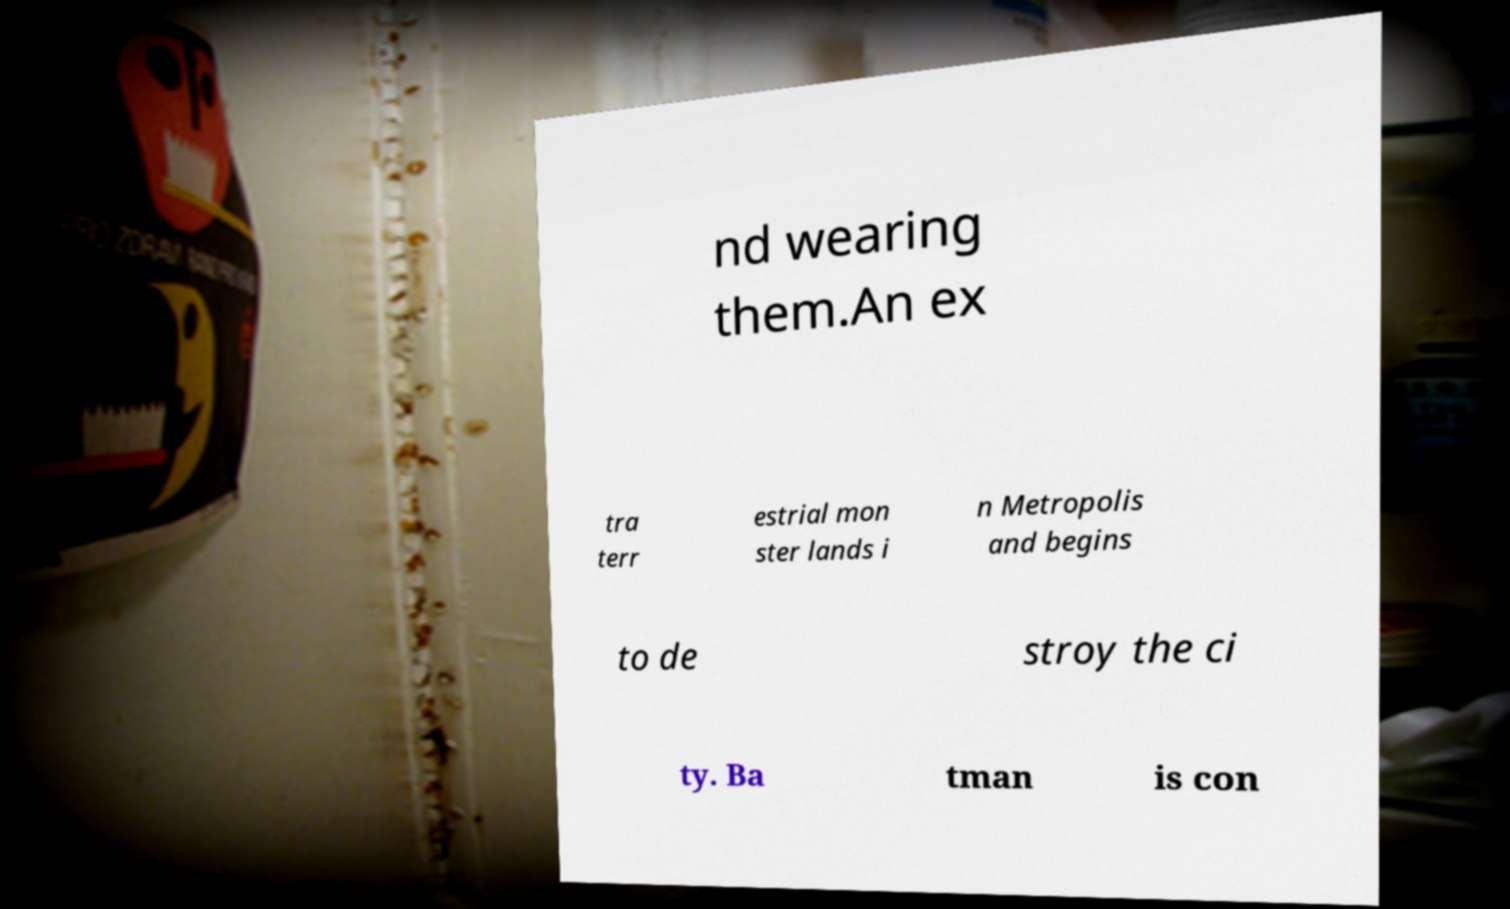What messages or text are displayed in this image? I need them in a readable, typed format. nd wearing them.An ex tra terr estrial mon ster lands i n Metropolis and begins to de stroy the ci ty. Ba tman is con 